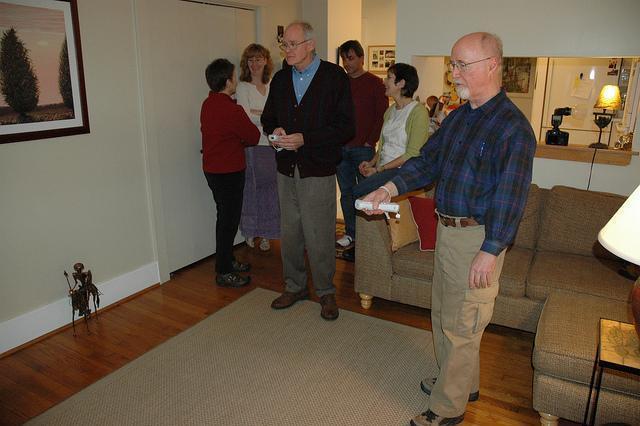How many people are standing?
Give a very brief answer. 6. How many people are female?
Give a very brief answer. 3. How many people are in the photo?
Give a very brief answer. 6. How many people are there?
Give a very brief answer. 6. How many couches are in the picture?
Give a very brief answer. 2. 